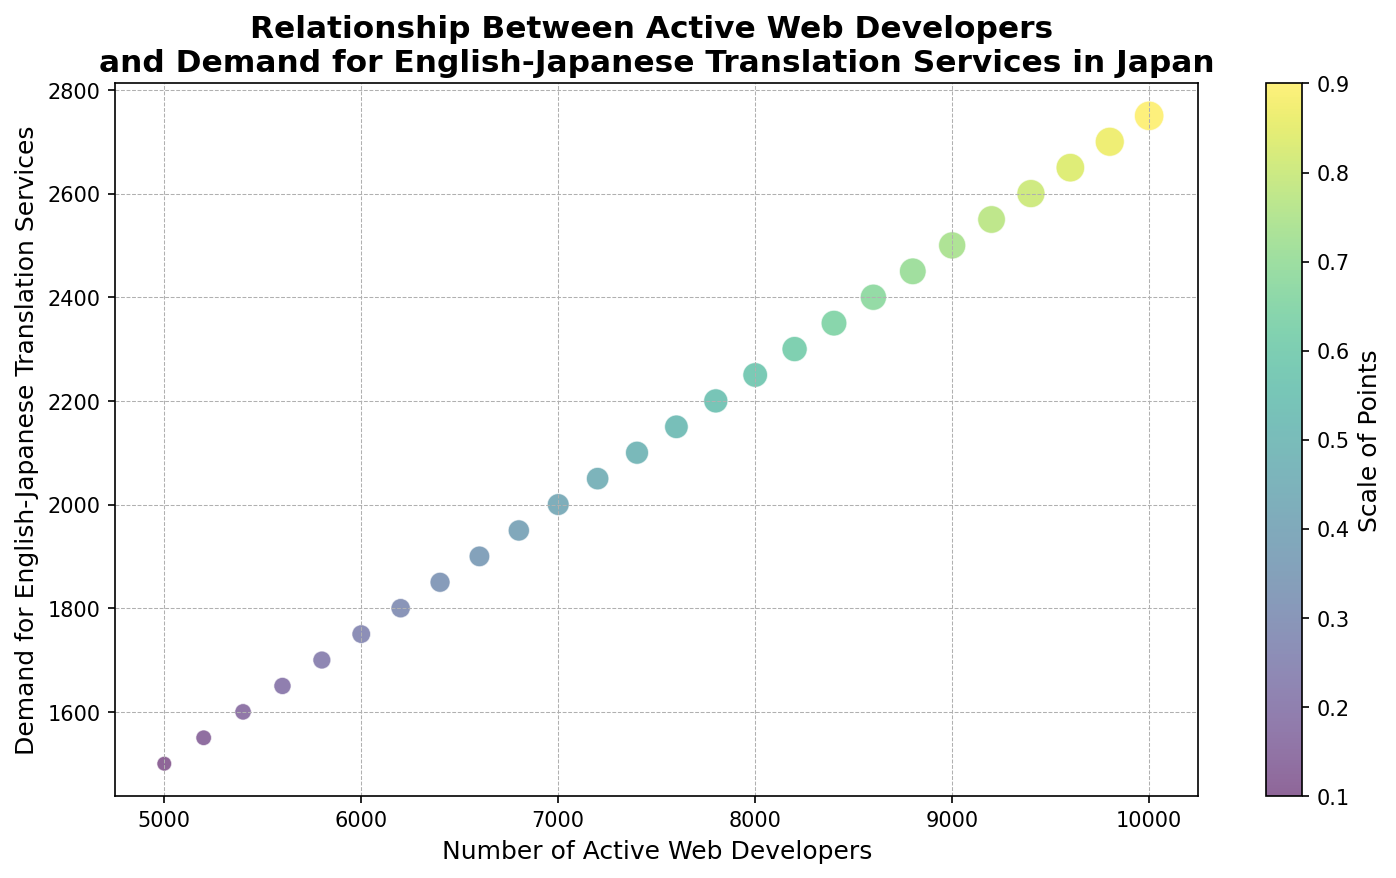What trend can be observed between the number of active web developers and the demand for English-Japanese translation services? The scatter plot shows that as the number of active web developers increases, the demand for English-Japanese translation services also increases.
Answer: Positive Correlation Which data point corresponds to the highest demand for English-Japanese translation services, and how many active web developers are there for this data point? The highest demand for English-Japanese translation services is 2750, which corresponds to 10,000 active web developers. This can be seen from the top right data point in the scatter plot.
Answer: 10,000 active web developers By how much does the demand for English-Japanese translation services increase when the number of active web developers rises from 7000 to 9000? The demand for English-Japanese translation services at 7000 active web developers is 2000 and at 9000 active web developers is 2500. The increase in demand is 2500 - 2000 = 500.
Answer: 500 How does the size of the points change as the number of active web developers increases, and what might this indicate? The sizes of the points increase as the number of active web developers increases. This indicates that the visual representation scales the size of data points with the number of web developers, possibly to emphasize the data proportionally.
Answer: Increasing Compare the demand for translation services at 7400 and 8200 active web developers. Which has a higher demand and by how much? At 7400 active web developers, the demand is 2100. At 8200 active web developers, the demand is 2300. The demand at 8200 active web developers is higher by 2300 - 2100 = 200.
Answer: 8200, by 200 